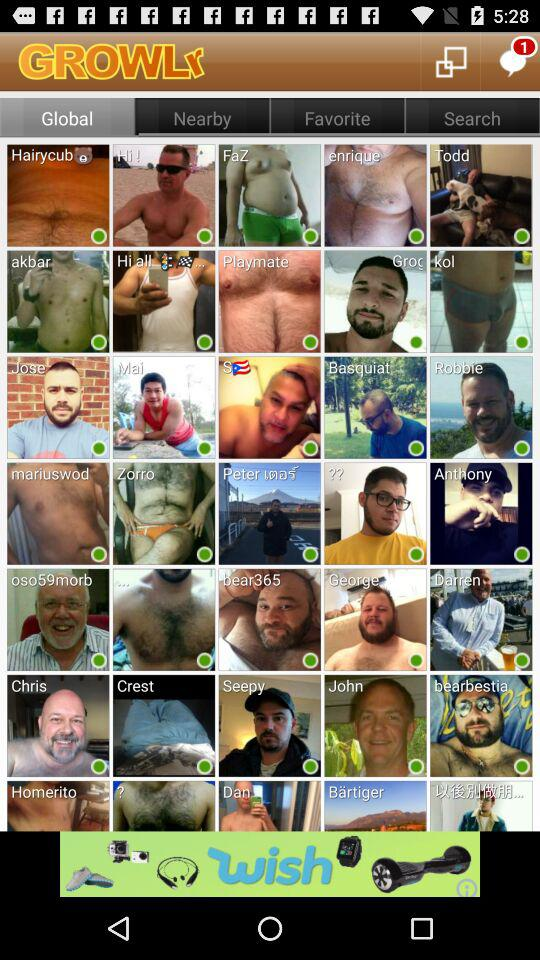What is the name of the application? The name of the application is "GROWLr". 